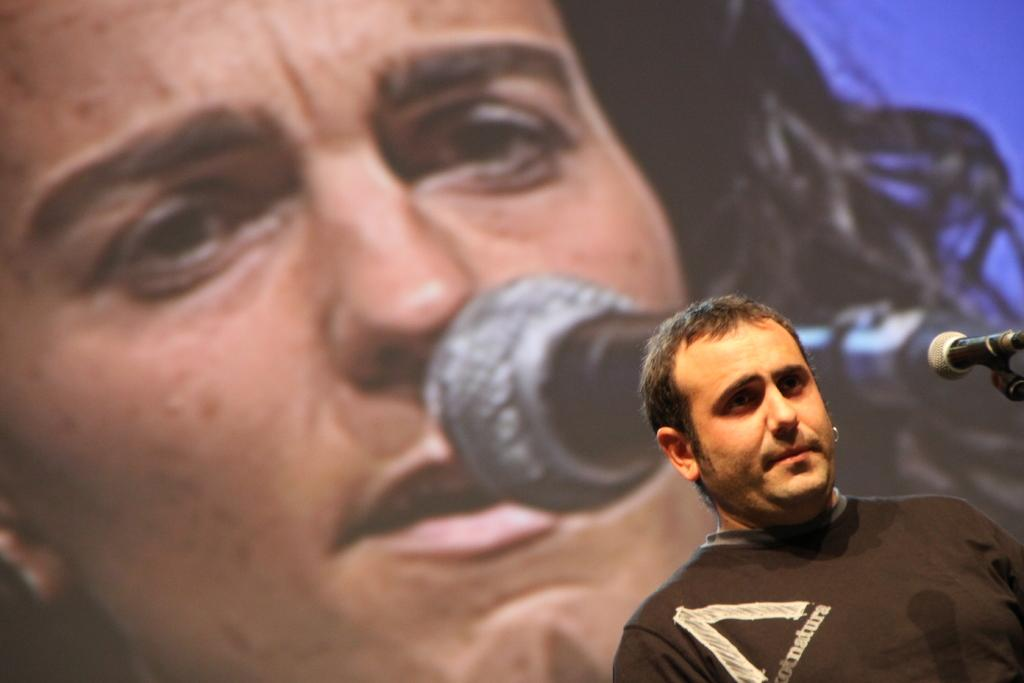What is the man in the image holding? The man is holding a microphone. What is the man wearing in the image? The man is wearing a black dress. Is there any other image or object related to the man and the microphone in the image? Yes, there is an image of a man and a microphone in the background of the image. How many spiders are crawling on the edge of the microphone in the image? There are no spiders present in the image, and therefore no spiders are crawling on the edge of the microphone. What is the man's love interest in the image? There is no information about the man's love interest in the image. 